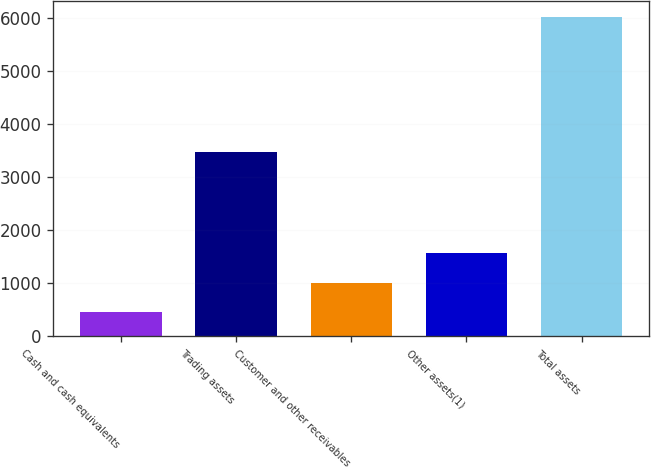Convert chart to OTSL. <chart><loc_0><loc_0><loc_500><loc_500><bar_chart><fcel>Cash and cash equivalents<fcel>Trading assets<fcel>Customer and other receivables<fcel>Other assets(1)<fcel>Total assets<nl><fcel>460<fcel>3480<fcel>1016.2<fcel>1572.4<fcel>6022<nl></chart> 